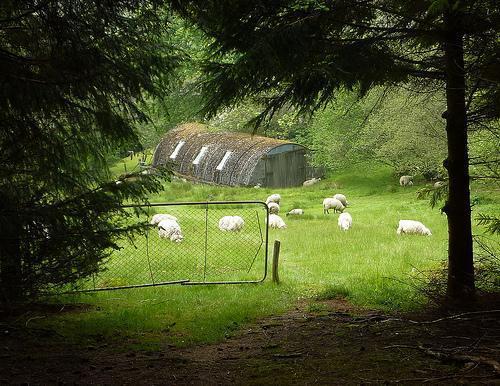How many building do you see?
Give a very brief answer. 1. How many sheep are in the picture?
Give a very brief answer. 13. 